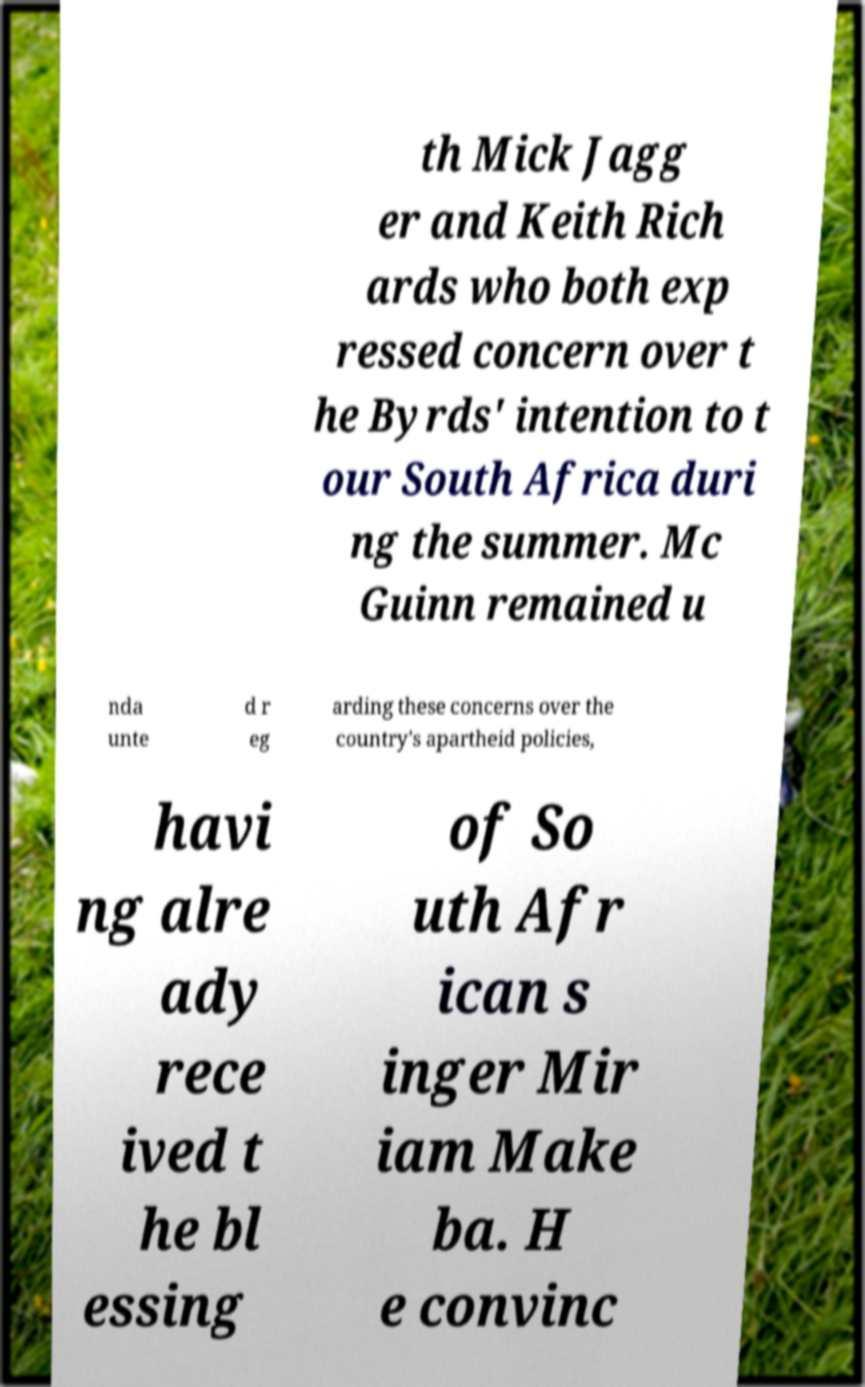For documentation purposes, I need the text within this image transcribed. Could you provide that? th Mick Jagg er and Keith Rich ards who both exp ressed concern over t he Byrds' intention to t our South Africa duri ng the summer. Mc Guinn remained u nda unte d r eg arding these concerns over the country's apartheid policies, havi ng alre ady rece ived t he bl essing of So uth Afr ican s inger Mir iam Make ba. H e convinc 